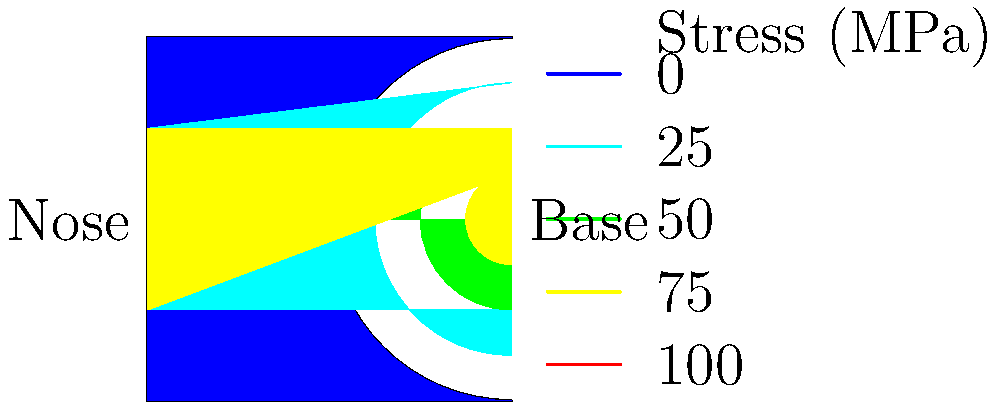In the color-coded stress distribution diagram of a rocket fuselage, which region experiences the highest stress, and what factors might contribute to this stress concentration? To analyze the stress distribution in the rocket fuselage:

1. Observe the color scheme: The diagram uses a color gradient from blue (low stress) to red (high stress).

2. Identify high-stress areas: The red region near the base of the rocket indicates the highest stress concentration.

3. Consider contributing factors:
   a) Propulsion forces: The base experiences thrust from the engines during launch.
   b) Aerodynamic loads: As the rocket accelerates, it encounters increasing air resistance.
   c) Structural discontinuities: The transition from the cylindrical body to the base can create stress concentrations.
   d) Weight distribution: The fuel mass and payload above add compressive stress to the base.

4. Analyze stress variation:
   The stress gradually decreases from the base to the nose, as shown by the color transition from red to blue.

5. Engineering implications:
   This stress distribution informs design decisions, such as material selection, reinforcement placement, and potential need for additional support structures at the base.

Understanding this stress distribution is crucial for ensuring the structural integrity of the rocket fuselage during launch and flight.
Answer: Base region; due to propulsion forces, aerodynamic loads, structural discontinuities, and weight distribution. 